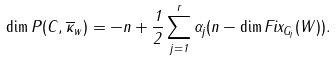<formula> <loc_0><loc_0><loc_500><loc_500>\dim P ( C , \overline { \kappa } _ { w } ) = - n + \frac { 1 } { 2 } \sum _ { j = 1 } ^ { r } \alpha _ { j } ( n - \dim F i x _ { G _ { j } } ( W ) ) .</formula> 